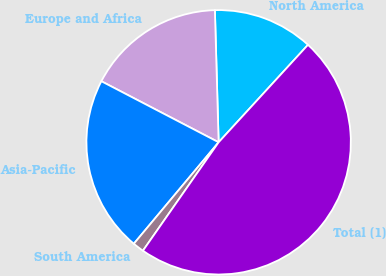<chart> <loc_0><loc_0><loc_500><loc_500><pie_chart><fcel>North America<fcel>Europe and Africa<fcel>Asia-Pacific<fcel>South America<fcel>Total (1)<nl><fcel>12.26%<fcel>16.91%<fcel>21.56%<fcel>1.38%<fcel>47.89%<nl></chart> 